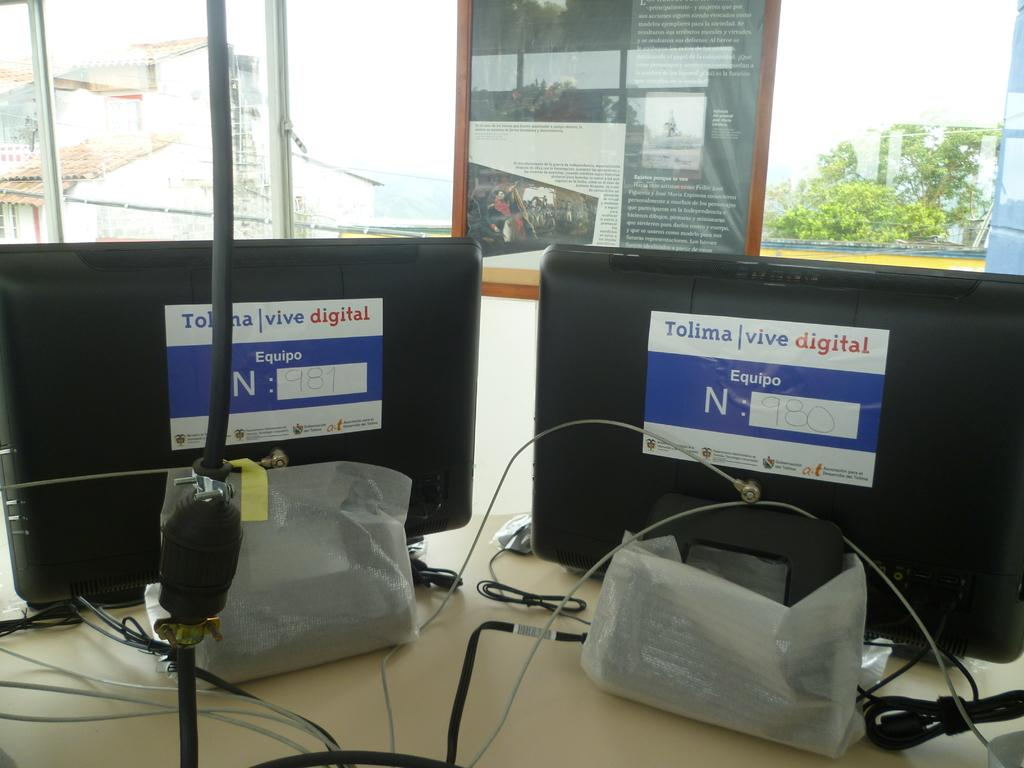<image>
Share a concise interpretation of the image provided. Monitors that say Tolima vive digital on the back. 